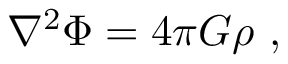<formula> <loc_0><loc_0><loc_500><loc_500>\nabla ^ { 2 } \Phi = 4 \pi G \rho \ ,</formula> 